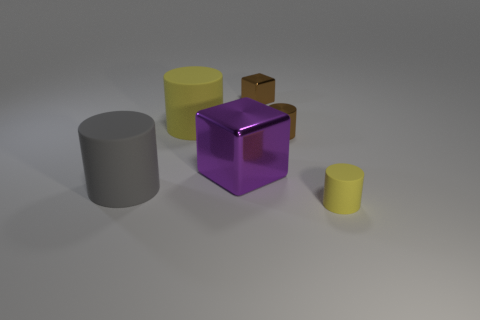Do the tiny block and the shiny cylinder that is behind the large shiny thing have the same color?
Give a very brief answer. Yes. There is a object left of the yellow object to the left of the cylinder that is in front of the gray object; what color is it?
Offer a very short reply. Gray. Are there any cyan shiny things that have the same shape as the large yellow rubber object?
Your response must be concise. No. What color is the other rubber cylinder that is the same size as the gray rubber cylinder?
Your answer should be compact. Yellow. What is the material of the yellow cylinder left of the tiny brown metal cylinder?
Offer a terse response. Rubber. There is a yellow matte object behind the purple thing; is it the same shape as the purple shiny thing behind the small yellow thing?
Offer a terse response. No. Are there the same number of gray cylinders that are in front of the small yellow cylinder and big gray balls?
Make the answer very short. Yes. How many brown cylinders have the same material as the purple block?
Ensure brevity in your answer.  1. What is the color of the large object that is the same material as the tiny brown cylinder?
Your answer should be compact. Purple. Is the size of the brown shiny block the same as the rubber thing that is behind the large purple thing?
Keep it short and to the point. No. 